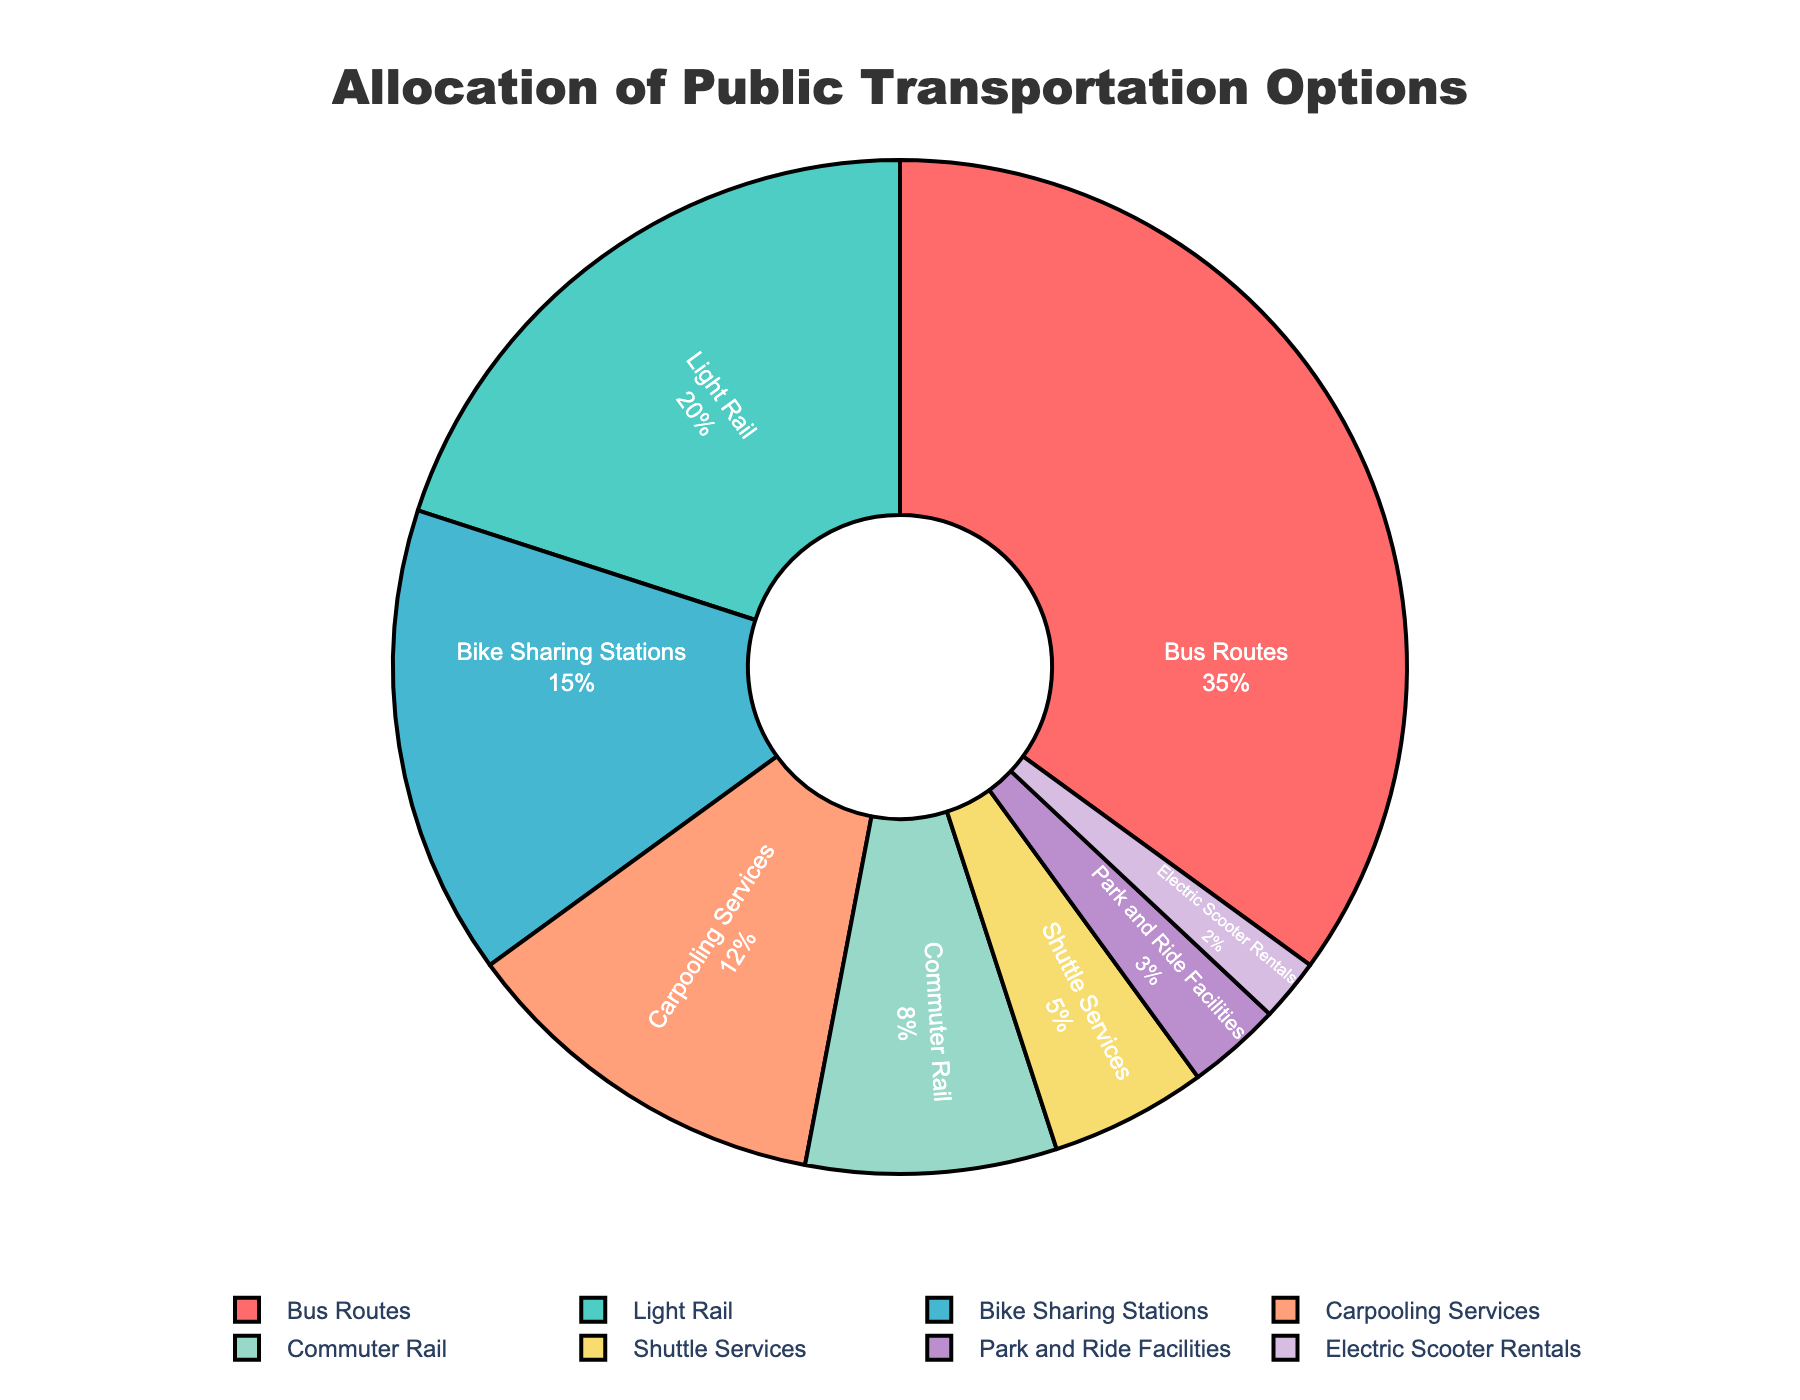What is the most common public transportation option? The largest slice in the pie chart represents Bus Routes.
Answer: Bus Routes Which transportation option has the smallest allocation? The smallest slice in the pie chart represents Electric Scooter Rentals.
Answer: Electric Scooter Rentals How much more allocation percentage do Bus Routes have compared to Light Rail? Bus Routes have 35%, and Light Rail has 20%. The difference is 35% - 20%.
Answer: 15% What is the total percentage allocation of Bike Sharing Stations and Carpooling Services combined? Bike Sharing Stations have 15%, and Carpooling Services have 12%. Their combined percentage is 15% + 12%.
Answer: 27% Which two transportation options have a combined allocation equal to the Light Rail's allocation? Electric Scooter Rentals (2%) + Park and Ride Facilities (3%) equals 5%, which is not equal to Light Rail's 20%. Shuttle Services (5%) + Electric Scooter Rentals (2%) equals 7%, still not equal. Considering every combination, we find Carpooling Services (12%) + Commuter Rail (8%) equals 20%.
Answer: Carpooling Services and Commuter Rail Is the allocation percentage of Light Rail greater than the total allocation percentage of Shuttle Services and Park and Ride Facilities combined? Light Rail has 20%, while Shuttle Services have 5% and Park and Ride Facilities have 3%. Their combined percentage is 5% + 3% = 8%, which is less than 20%.
Answer: Yes What is the average allocation percentage of the top three transportation options? The top three options are Bus Routes (35%), Light Rail (20%), and Bike Sharing Stations (15%). The average is (35% + 20% + 15%) / 3.
Answer: 23.33% Which transportation option has an equal allocation to the sum of Park and Ride Facilities and Electric Scooter Rentals? Park and Ride Facilities have 3%, and Electric Scooter Rentals have 2%. Their combined percentage is 3% + 2% = 5%. Shuttle Services have an equal allocation at 5%.
Answer: Shuttle Services 